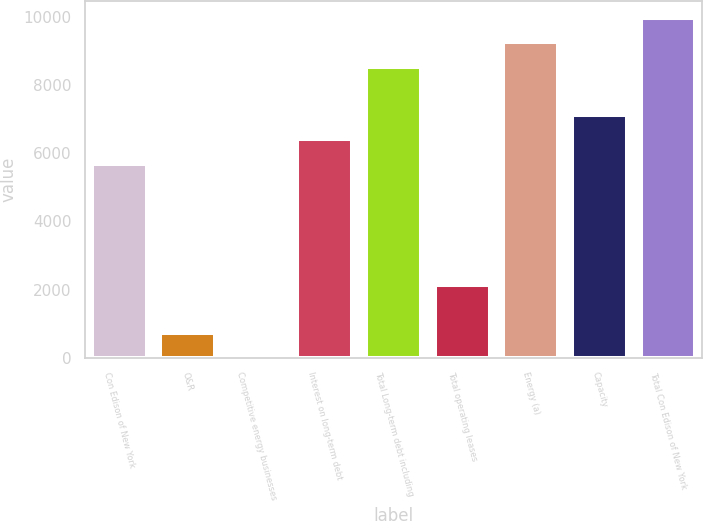Convert chart to OTSL. <chart><loc_0><loc_0><loc_500><loc_500><bar_chart><fcel>Con Edison of New York<fcel>O&R<fcel>Competitive energy businesses<fcel>Interest on long-term debt<fcel>Total Long-term debt including<fcel>Total operating leases<fcel>Energy (a)<fcel>Capacity<fcel>Total Con Edison of New York<nl><fcel>5696<fcel>715.5<fcel>4<fcel>6407.5<fcel>8542<fcel>2138.5<fcel>9253.5<fcel>7119<fcel>9965<nl></chart> 